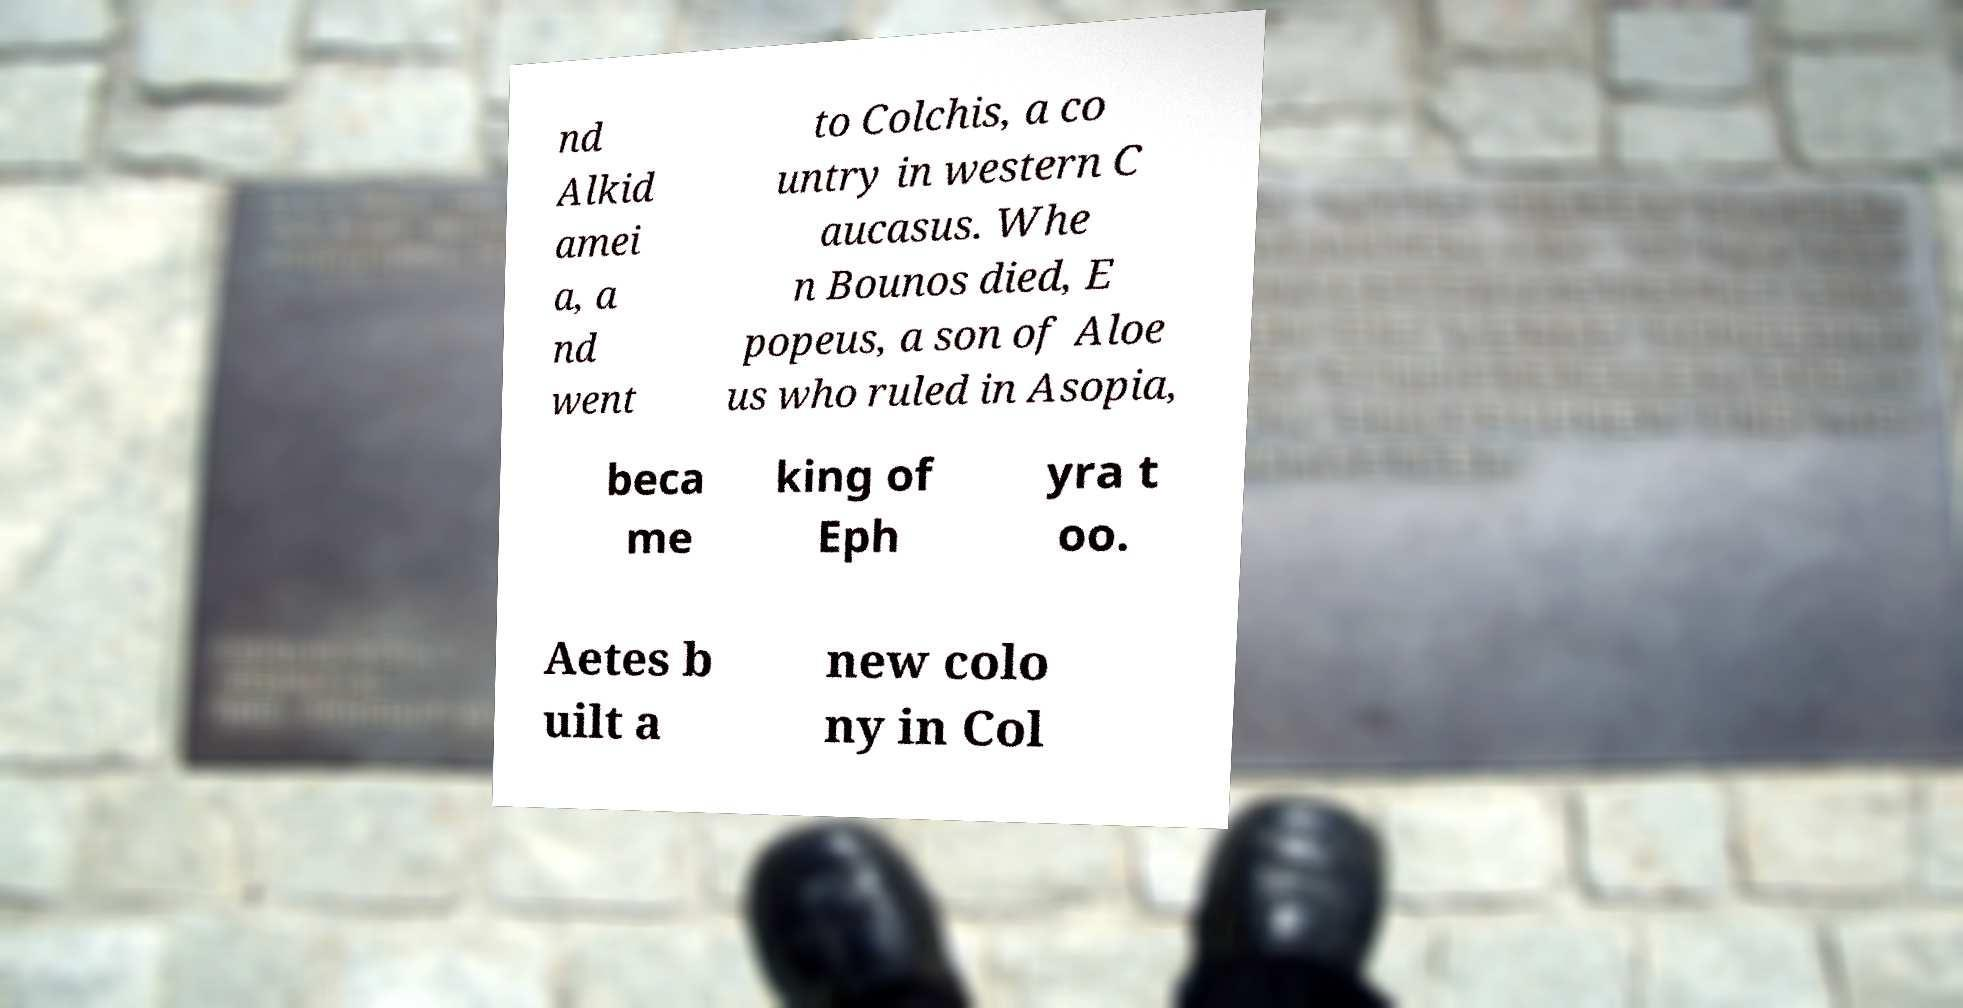Please read and relay the text visible in this image. What does it say? nd Alkid amei a, a nd went to Colchis, a co untry in western C aucasus. Whe n Bounos died, E popeus, a son of Aloe us who ruled in Asopia, beca me king of Eph yra t oo. Aetes b uilt a new colo ny in Col 